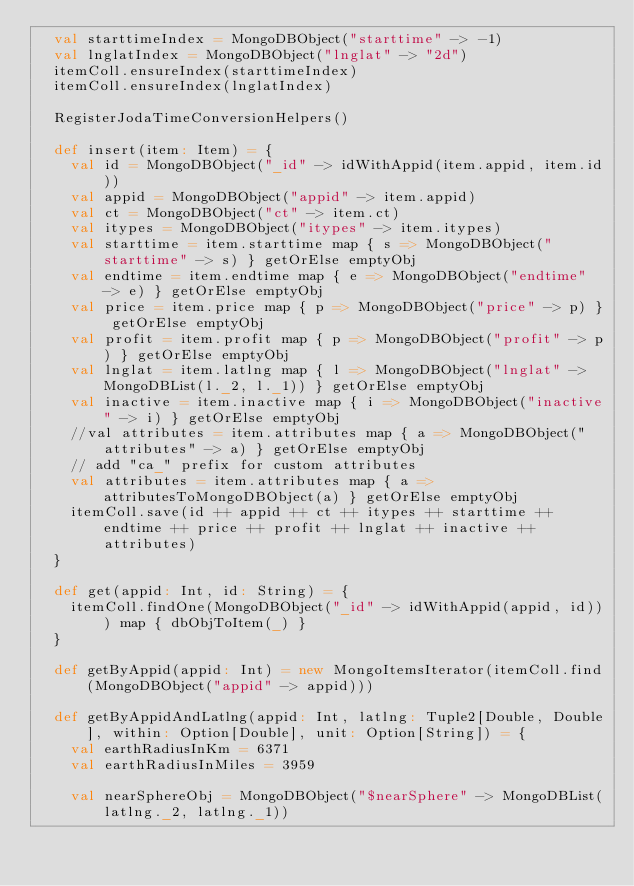Convert code to text. <code><loc_0><loc_0><loc_500><loc_500><_Scala_>  val starttimeIndex = MongoDBObject("starttime" -> -1)
  val lnglatIndex = MongoDBObject("lnglat" -> "2d")
  itemColl.ensureIndex(starttimeIndex)
  itemColl.ensureIndex(lnglatIndex)

  RegisterJodaTimeConversionHelpers()

  def insert(item: Item) = {
    val id = MongoDBObject("_id" -> idWithAppid(item.appid, item.id))
    val appid = MongoDBObject("appid" -> item.appid)
    val ct = MongoDBObject("ct" -> item.ct)
    val itypes = MongoDBObject("itypes" -> item.itypes)
    val starttime = item.starttime map { s => MongoDBObject("starttime" -> s) } getOrElse emptyObj
    val endtime = item.endtime map { e => MongoDBObject("endtime" -> e) } getOrElse emptyObj
    val price = item.price map { p => MongoDBObject("price" -> p) } getOrElse emptyObj
    val profit = item.profit map { p => MongoDBObject("profit" -> p) } getOrElse emptyObj
    val lnglat = item.latlng map { l => MongoDBObject("lnglat" -> MongoDBList(l._2, l._1)) } getOrElse emptyObj
    val inactive = item.inactive map { i => MongoDBObject("inactive" -> i) } getOrElse emptyObj
    //val attributes = item.attributes map { a => MongoDBObject("attributes" -> a) } getOrElse emptyObj
    // add "ca_" prefix for custom attributes
    val attributes = item.attributes map { a => attributesToMongoDBObject(a) } getOrElse emptyObj
    itemColl.save(id ++ appid ++ ct ++ itypes ++ starttime ++ endtime ++ price ++ profit ++ lnglat ++ inactive ++ attributes)
  }

  def get(appid: Int, id: String) = {
    itemColl.findOne(MongoDBObject("_id" -> idWithAppid(appid, id))) map { dbObjToItem(_) }
  }

  def getByAppid(appid: Int) = new MongoItemsIterator(itemColl.find(MongoDBObject("appid" -> appid)))

  def getByAppidAndLatlng(appid: Int, latlng: Tuple2[Double, Double], within: Option[Double], unit: Option[String]) = {
    val earthRadiusInKm = 6371
    val earthRadiusInMiles = 3959

    val nearSphereObj = MongoDBObject("$nearSphere" -> MongoDBList(latlng._2, latlng._1))</code> 